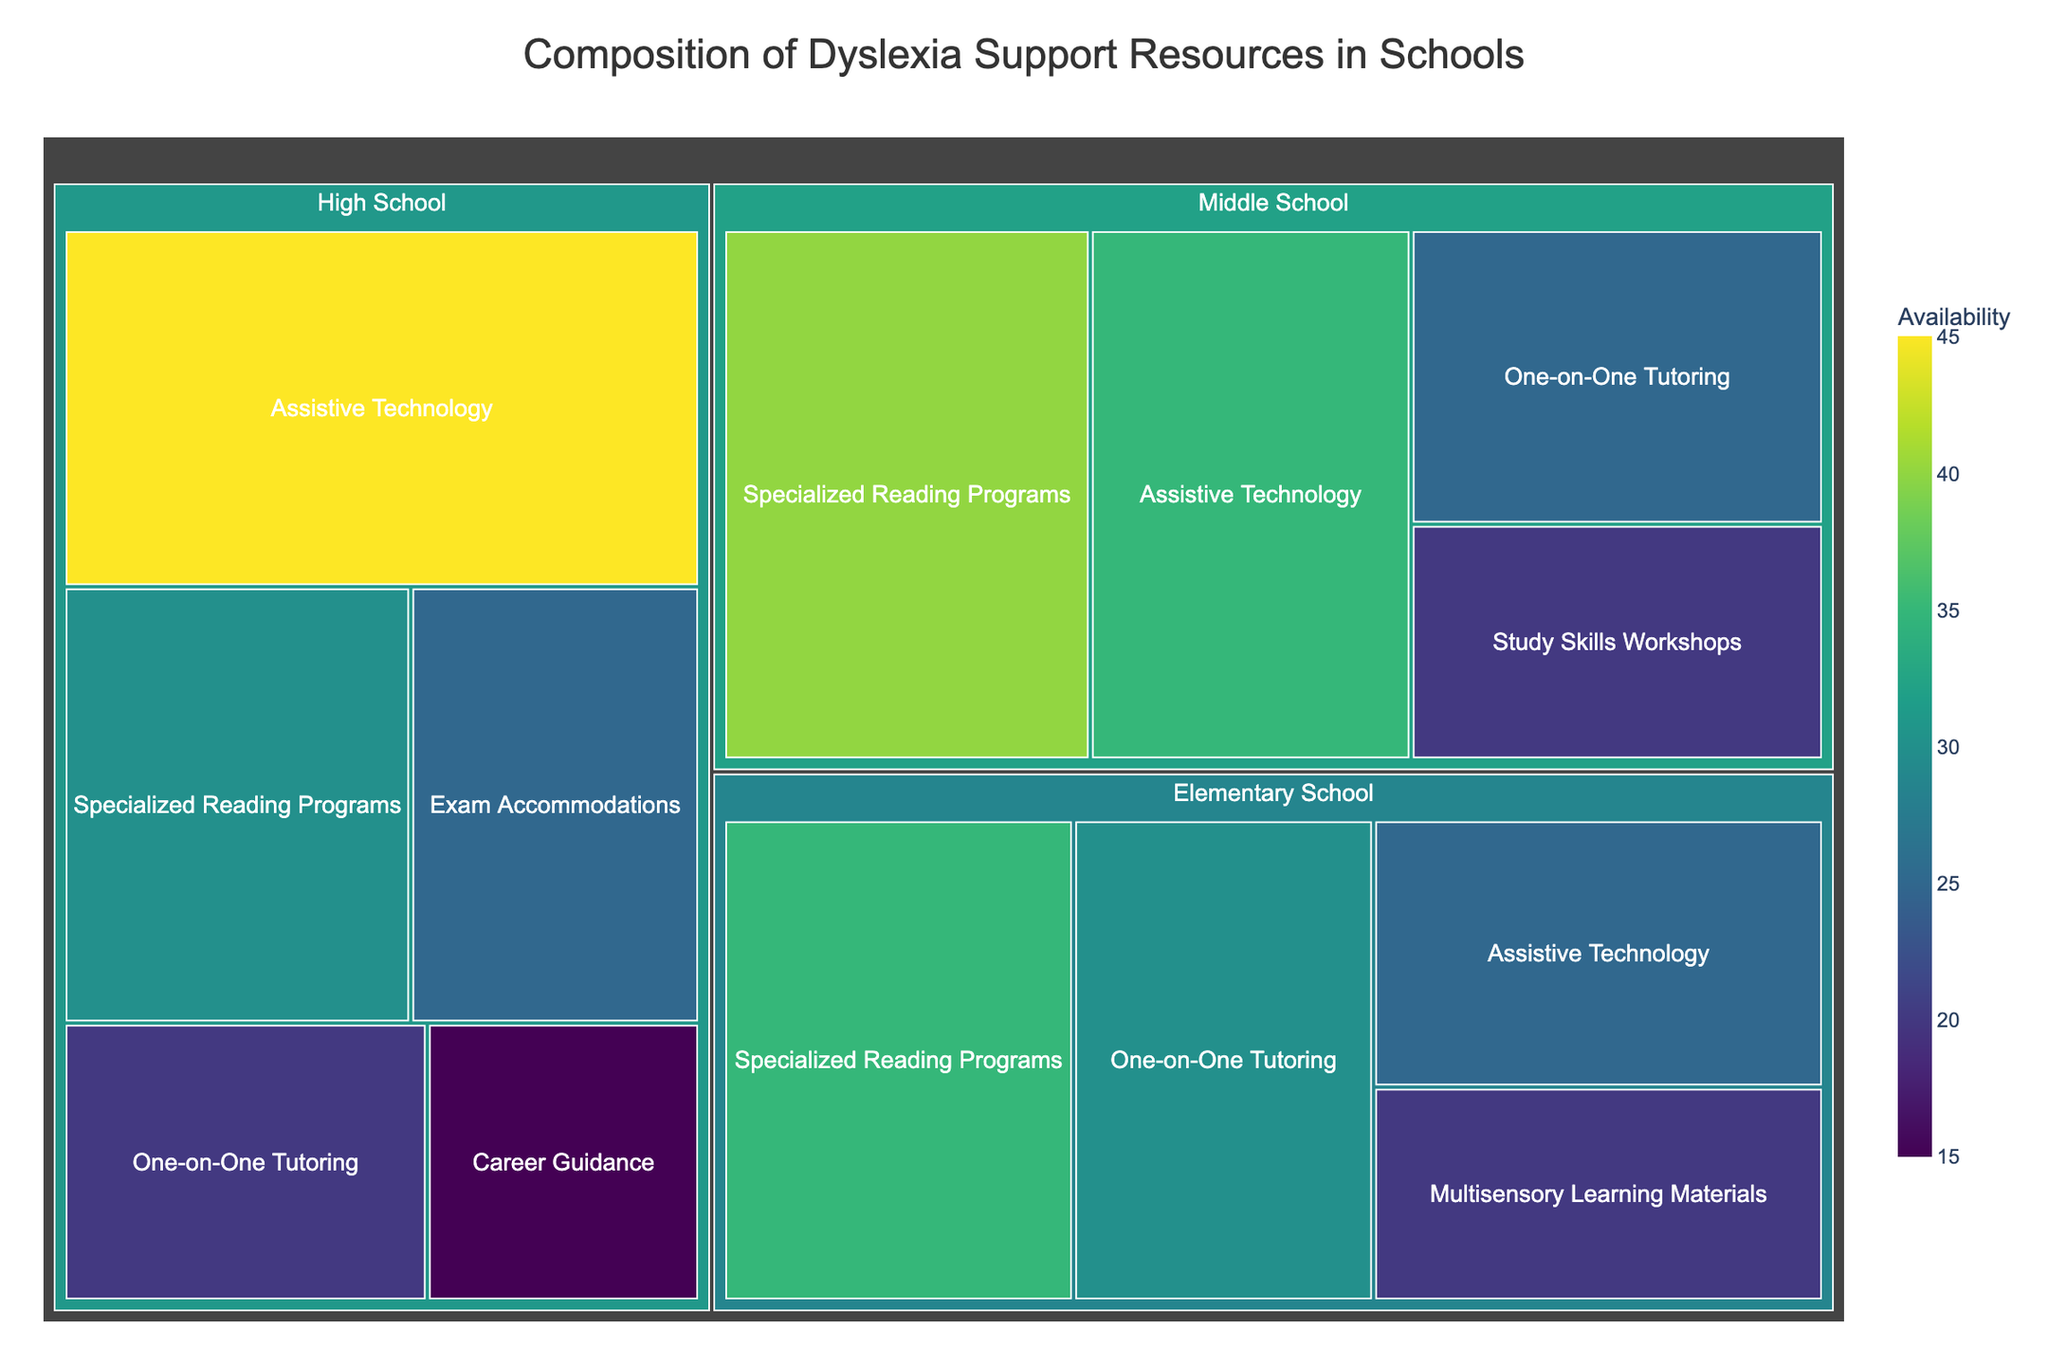What is the most available dyslexia support resource in High School? Look at the section for High School in the treemap and identify the resource with the highest value.
Answer: Assistive Technology Which education level has the least number of One-on-One Tutoring resources? Compare the values of One-on-One Tutoring across Elementary School, Middle School, and High School to find the lowest one.
Answer: High School How does the availability of Specialized Reading Programs compare between Elementary School and Middle School? Compare the numbers given for Specialized Reading Programs in both Elementary School and Middle School sections.
Answer: Middle School has more (40 vs 35) What's the total availability of dyslexia support resources in Elementary School? Sum the values of all dyslexia support resources listed under Elementary School.
Answer: 110 What is the ratio of the availability of Assistive Technology in High School to that in Elementary School? Divide the value of Assistive Technology in High School by the value in Elementary School.
Answer: 45:25 or 1.8 Which support resource is exclusively available in High School? Identify any unique resources listed only under High School and not in other categories.
Answer: Career Guidance How many more Specialized Reading Programs are available in Middle School compared to High School? Subtract the number of Specialized Reading Programs in High School from that in Middle School.
Answer: 10 Calculate the average availability of resources in Middle School. Sum all the values listed under Middle School and divide by the number of resources.
Answer: 30 Which education level has the most diverse range of dyslexia support resources? Count the number of unique support resources in each educational level's section of the treemap.
Answer: High School (5 resources) Compare the availability of Multisensory Learning Materials in Elementary School to Exam Accommodations in High School. Check the values for Multisensory Learning Materials in Elementary School and Exam Accommodations in High School, and compare them.
Answer: Multisensory Learning Materials: 20, Exam Accommodations: 25 